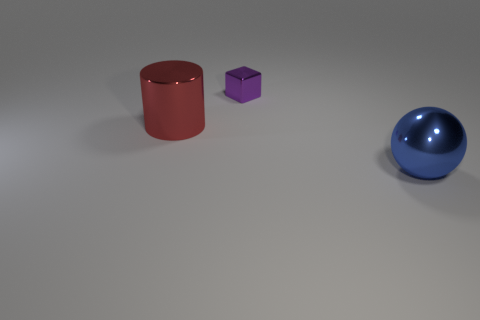Add 3 small purple metal cylinders. How many objects exist? 6 Subtract all cubes. How many objects are left? 2 Add 1 large red cylinders. How many large red cylinders exist? 2 Subtract 0 yellow blocks. How many objects are left? 3 Subtract all tiny purple cubes. Subtract all purple metallic things. How many objects are left? 1 Add 1 large metallic balls. How many large metallic balls are left? 2 